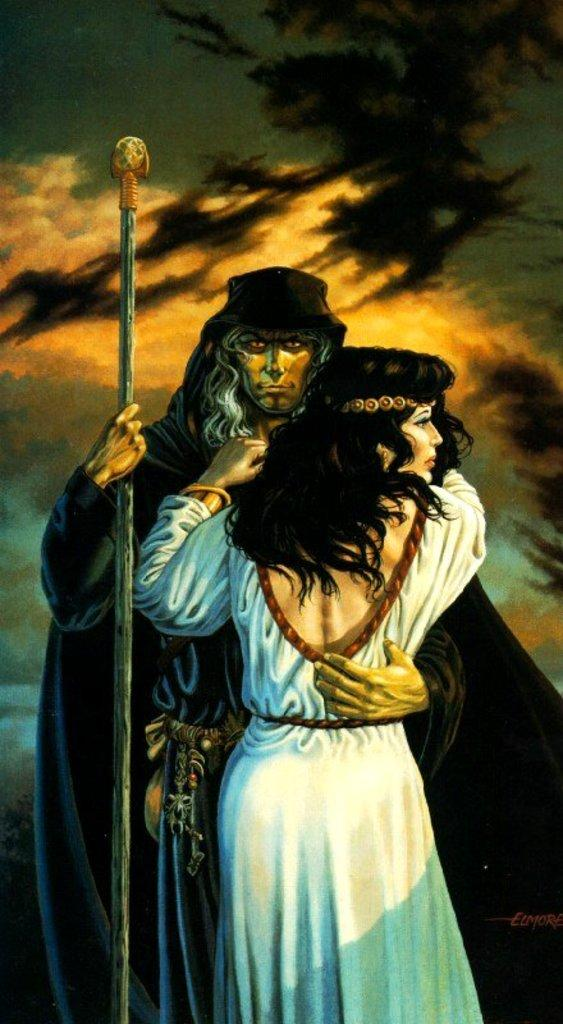How many people are in the image? There are persons in the image. What are the persons in the image doing? The persons are standing and hugging each other. Can you describe the man in the image? The man is holding a stick in the image. What type of glue is being used to hold the persons together in the image? There is no glue present in the image; the persons are hugging each other. What is the man in the image afraid of? There is no indication of fear in the image; the man is holding a stick. 